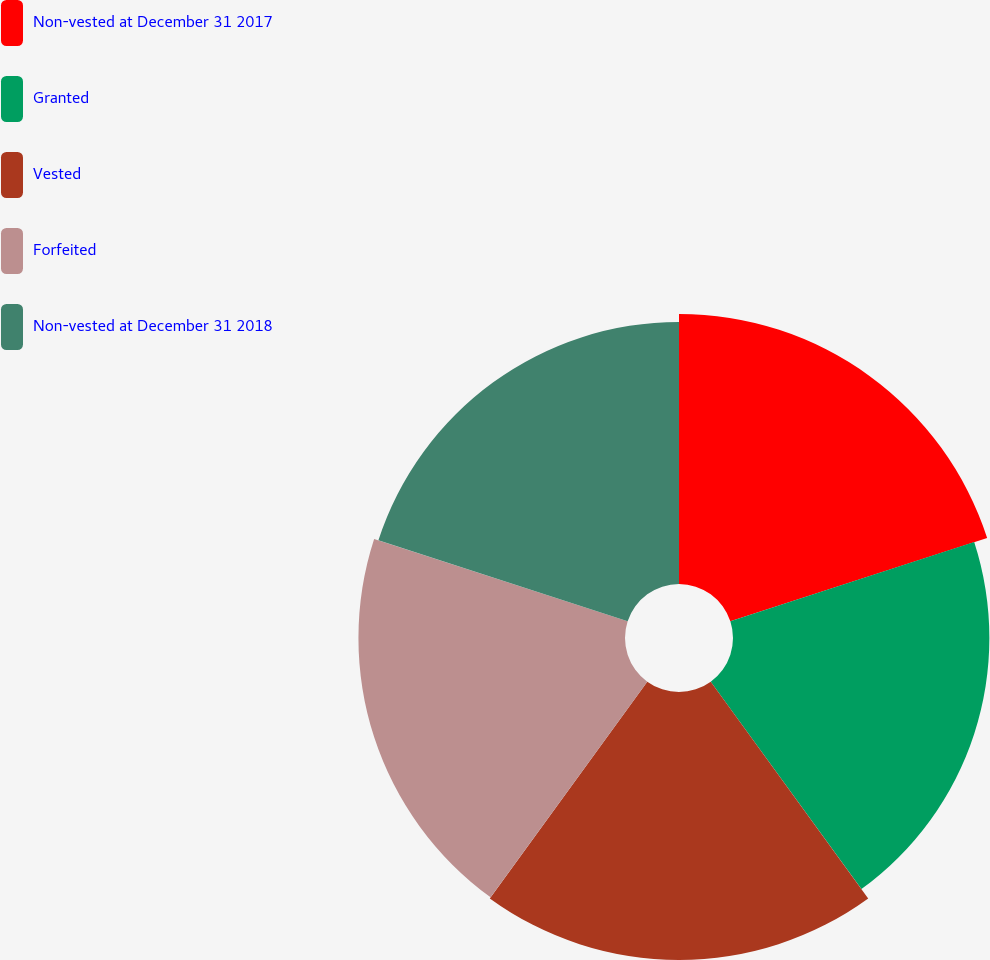Convert chart. <chart><loc_0><loc_0><loc_500><loc_500><pie_chart><fcel>Non-vested at December 31 2017<fcel>Granted<fcel>Vested<fcel>Forfeited<fcel>Non-vested at December 31 2018<nl><fcel>20.41%<fcel>19.38%<fcel>20.25%<fcel>20.15%<fcel>19.81%<nl></chart> 